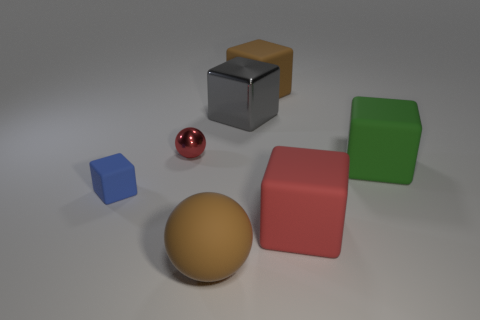There is a big brown object right of the large gray shiny cube; how many metallic cubes are behind it?
Give a very brief answer. 0. How many other objects are the same shape as the tiny shiny object?
Make the answer very short. 1. What number of things are either red balls or large rubber things that are to the left of the gray metallic block?
Your response must be concise. 2. Are there more big rubber objects that are behind the big green matte thing than small metal objects that are in front of the tiny red metal object?
Your response must be concise. Yes. What shape is the brown object that is left of the brown rubber thing that is behind the large brown thing that is in front of the blue matte block?
Provide a succinct answer. Sphere. What shape is the large brown matte object that is in front of the big rubber cube right of the large red thing?
Offer a very short reply. Sphere. Is there a large block that has the same material as the large gray object?
Give a very brief answer. No. What size is the rubber thing that is the same color as the small metal object?
Provide a short and direct response. Large. How many purple things are either cubes or large matte things?
Make the answer very short. 0. Are there any other tiny matte things of the same color as the tiny rubber thing?
Your answer should be compact. No. 